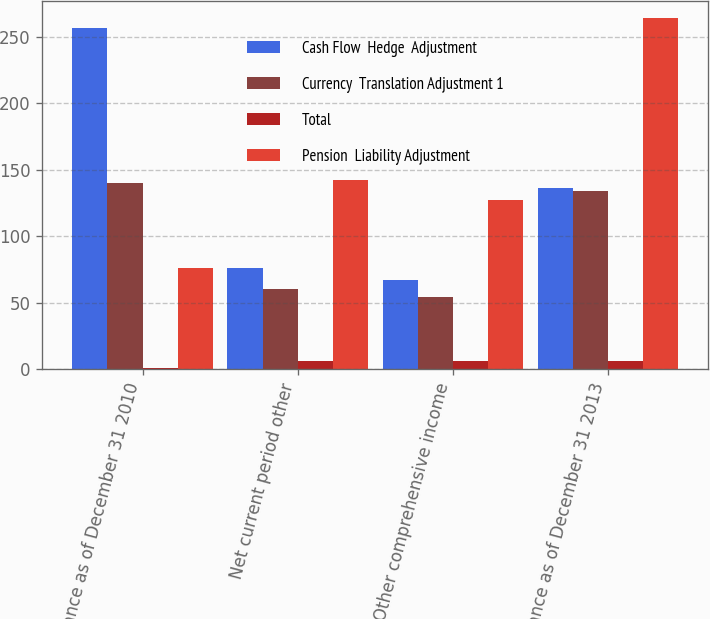Convert chart to OTSL. <chart><loc_0><loc_0><loc_500><loc_500><stacked_bar_chart><ecel><fcel>Balance as of December 31 2010<fcel>Net current period other<fcel>Other comprehensive income<fcel>Balance as of December 31 2013<nl><fcel>Cash Flow  Hedge  Adjustment<fcel>257<fcel>76<fcel>67<fcel>136<nl><fcel>Currency  Translation Adjustment 1<fcel>140<fcel>60<fcel>54<fcel>134<nl><fcel>Total<fcel>1<fcel>6<fcel>6<fcel>6<nl><fcel>Pension  Liability Adjustment<fcel>76<fcel>142<fcel>127<fcel>264<nl></chart> 